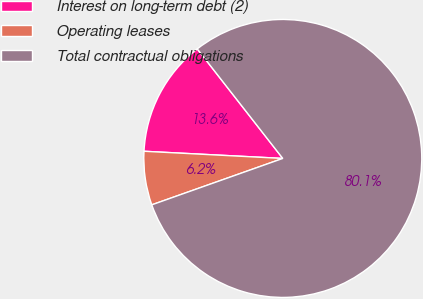Convert chart to OTSL. <chart><loc_0><loc_0><loc_500><loc_500><pie_chart><fcel>Interest on long-term debt (2)<fcel>Operating leases<fcel>Total contractual obligations<nl><fcel>13.63%<fcel>6.24%<fcel>80.14%<nl></chart> 